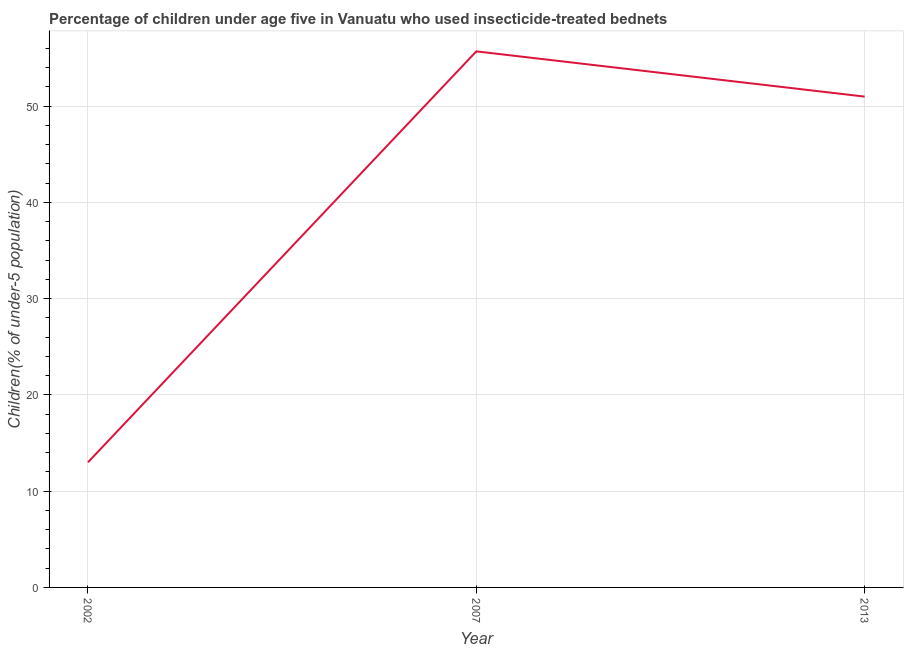Across all years, what is the maximum percentage of children who use of insecticide-treated bed nets?
Give a very brief answer. 55.7. Across all years, what is the minimum percentage of children who use of insecticide-treated bed nets?
Give a very brief answer. 13. What is the sum of the percentage of children who use of insecticide-treated bed nets?
Your response must be concise. 119.7. What is the difference between the percentage of children who use of insecticide-treated bed nets in 2002 and 2007?
Offer a very short reply. -42.7. What is the average percentage of children who use of insecticide-treated bed nets per year?
Ensure brevity in your answer.  39.9. In how many years, is the percentage of children who use of insecticide-treated bed nets greater than 6 %?
Give a very brief answer. 3. Do a majority of the years between 2013 and 2007 (inclusive) have percentage of children who use of insecticide-treated bed nets greater than 18 %?
Provide a succinct answer. No. What is the ratio of the percentage of children who use of insecticide-treated bed nets in 2002 to that in 2013?
Your answer should be compact. 0.25. Is the percentage of children who use of insecticide-treated bed nets in 2002 less than that in 2013?
Keep it short and to the point. Yes. What is the difference between the highest and the second highest percentage of children who use of insecticide-treated bed nets?
Give a very brief answer. 4.7. What is the difference between the highest and the lowest percentage of children who use of insecticide-treated bed nets?
Offer a very short reply. 42.7. Does the percentage of children who use of insecticide-treated bed nets monotonically increase over the years?
Your response must be concise. No. How many lines are there?
Make the answer very short. 1. What is the difference between two consecutive major ticks on the Y-axis?
Your answer should be very brief. 10. Does the graph contain grids?
Your response must be concise. Yes. What is the title of the graph?
Keep it short and to the point. Percentage of children under age five in Vanuatu who used insecticide-treated bednets. What is the label or title of the Y-axis?
Provide a succinct answer. Children(% of under-5 population). What is the Children(% of under-5 population) in 2007?
Provide a succinct answer. 55.7. What is the difference between the Children(% of under-5 population) in 2002 and 2007?
Ensure brevity in your answer.  -42.7. What is the difference between the Children(% of under-5 population) in 2002 and 2013?
Make the answer very short. -38. What is the ratio of the Children(% of under-5 population) in 2002 to that in 2007?
Your response must be concise. 0.23. What is the ratio of the Children(% of under-5 population) in 2002 to that in 2013?
Make the answer very short. 0.26. What is the ratio of the Children(% of under-5 population) in 2007 to that in 2013?
Keep it short and to the point. 1.09. 